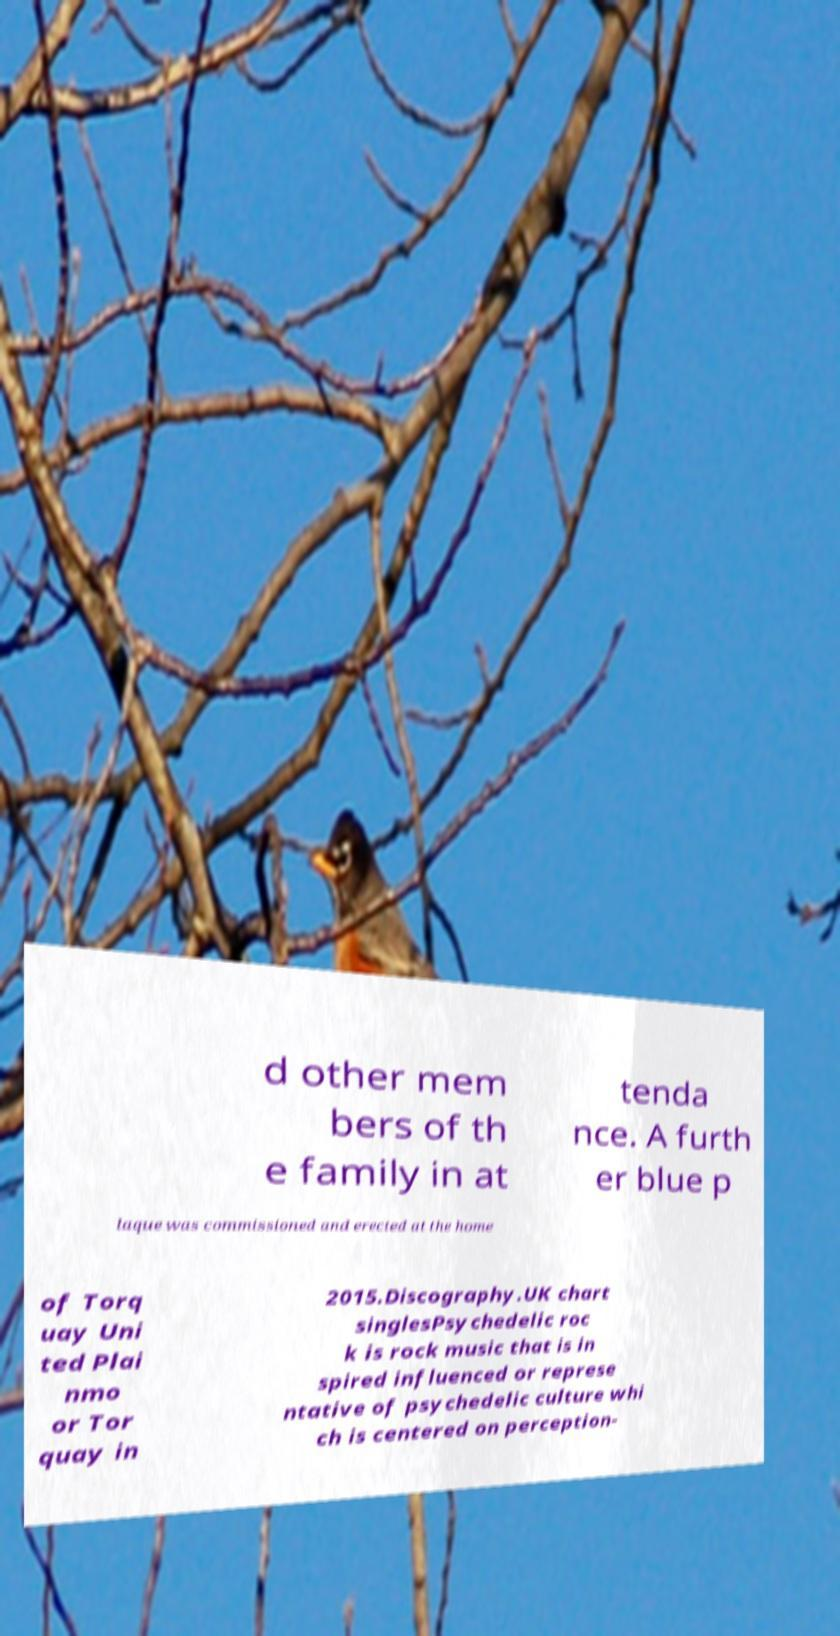Can you accurately transcribe the text from the provided image for me? d other mem bers of th e family in at tenda nce. A furth er blue p laque was commissioned and erected at the home of Torq uay Uni ted Plai nmo or Tor quay in 2015.Discography.UK chart singlesPsychedelic roc k is rock music that is in spired influenced or represe ntative of psychedelic culture whi ch is centered on perception- 